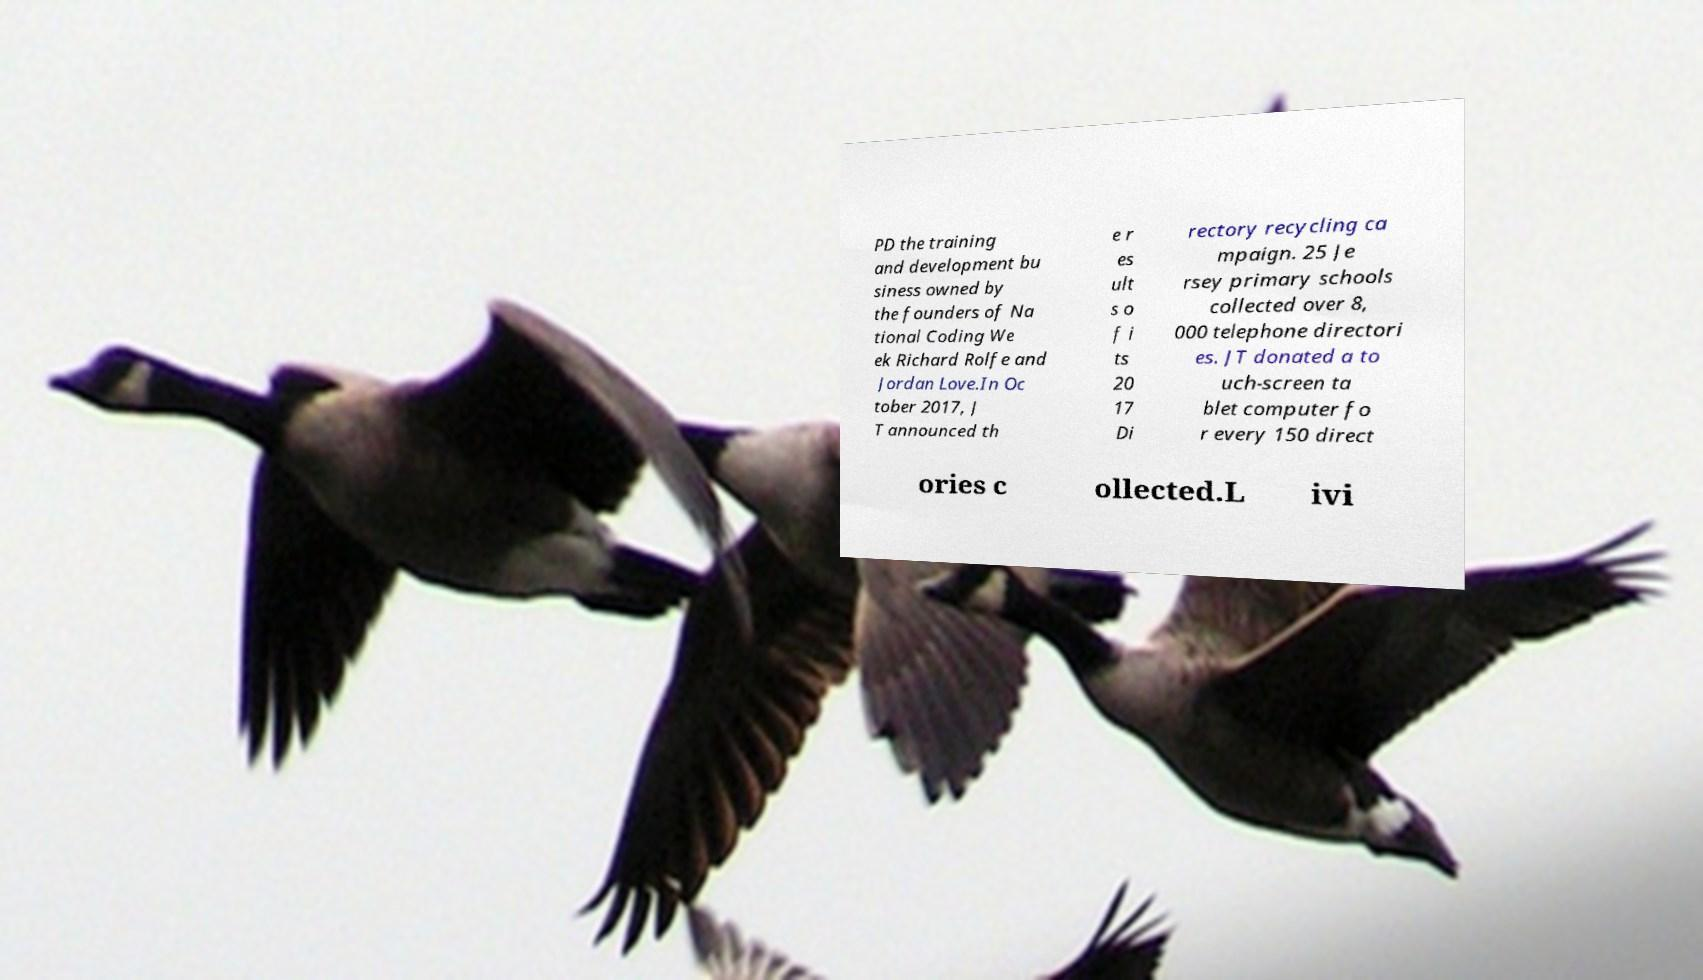Please identify and transcribe the text found in this image. PD the training and development bu siness owned by the founders of Na tional Coding We ek Richard Rolfe and Jordan Love.In Oc tober 2017, J T announced th e r es ult s o f i ts 20 17 Di rectory recycling ca mpaign. 25 Je rsey primary schools collected over 8, 000 telephone directori es. JT donated a to uch-screen ta blet computer fo r every 150 direct ories c ollected.L ivi 